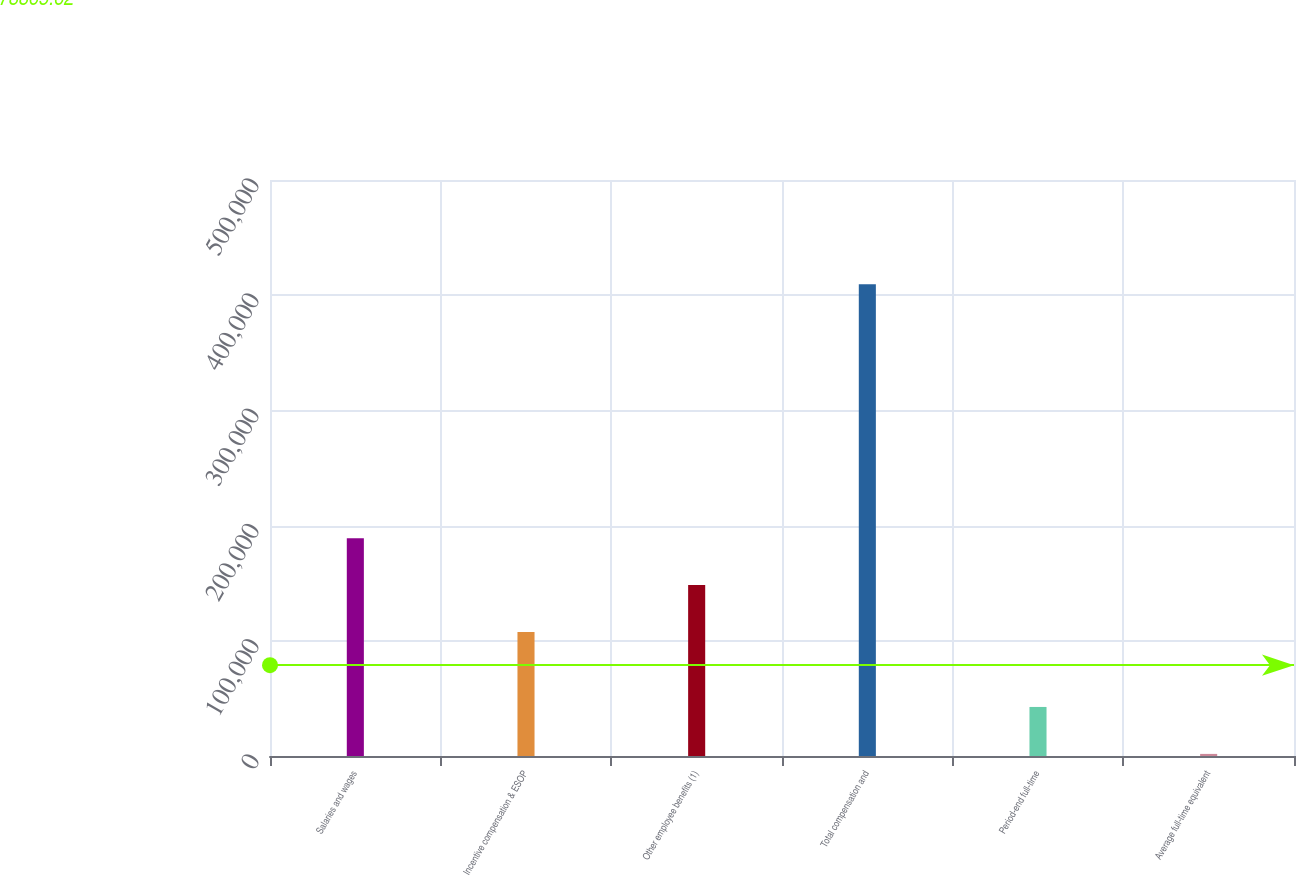<chart> <loc_0><loc_0><loc_500><loc_500><bar_chart><fcel>Salaries and wages<fcel>Incentive compensation & ESOP<fcel>Other employee benefits (1)<fcel>Total compensation and<fcel>Period-end full-time<fcel>Average full-time equivalent<nl><fcel>189098<fcel>107564<fcel>148331<fcel>409486<fcel>42582.1<fcel>1815<nl></chart> 